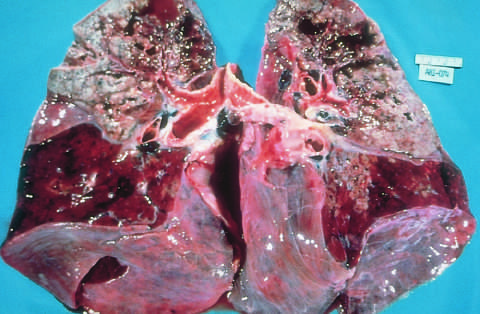what are the upper parts of both lungs riddled with?
Answer the question using a single word or phrase. The gray-white areas of caseation and multiple areas of softening and cavitation 